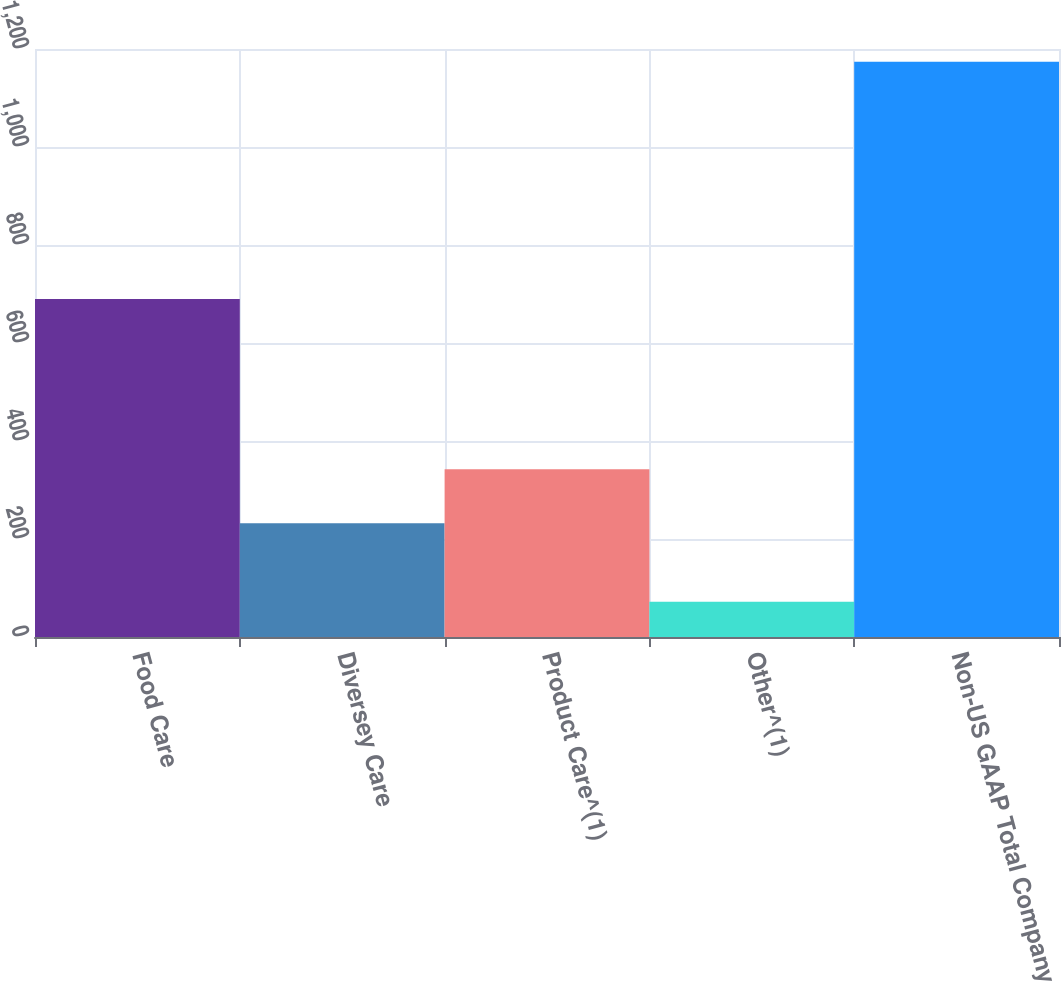Convert chart to OTSL. <chart><loc_0><loc_0><loc_500><loc_500><bar_chart><fcel>Food Care<fcel>Diversey Care<fcel>Product Care^(1)<fcel>Other^(1)<fcel>Non-US GAAP Total Company<nl><fcel>689.8<fcel>231.9<fcel>342.14<fcel>71.7<fcel>1174.1<nl></chart> 